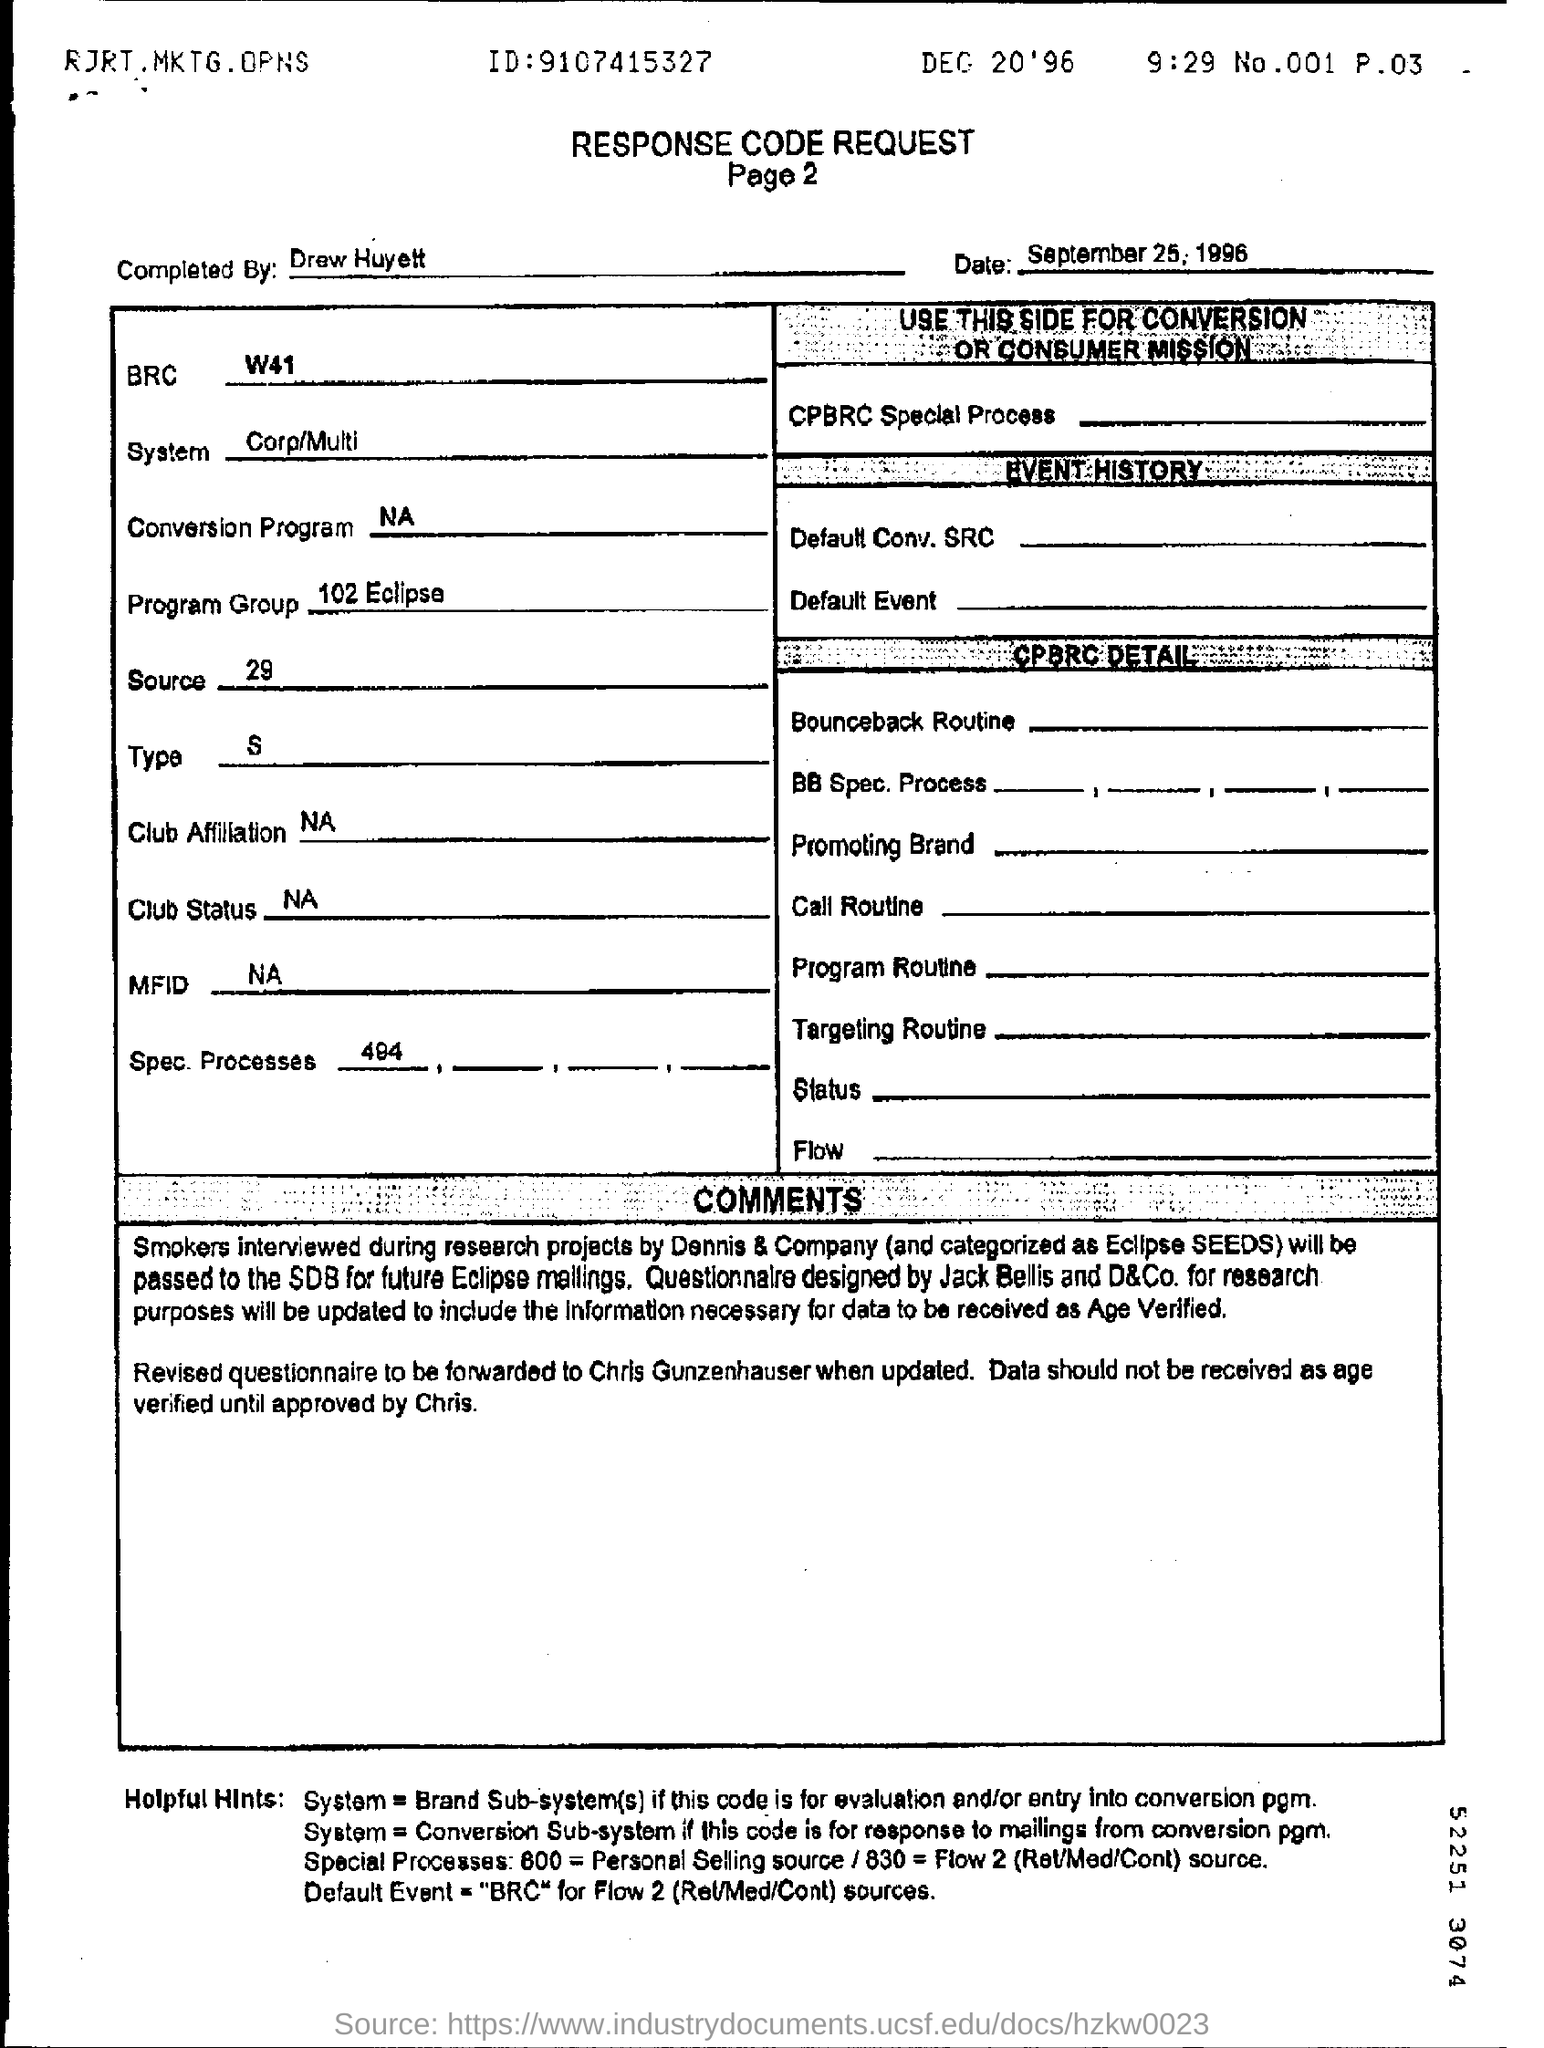Mention a couple of crucial points in this snapshot. The heading of the document is 'Response Code Request.' The date mentioned above the table is September 25, 1996. The document was completed by Drew Huyett. 